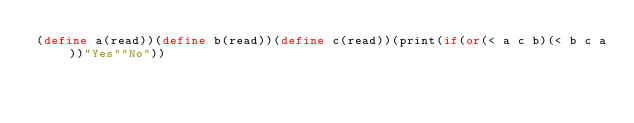Convert code to text. <code><loc_0><loc_0><loc_500><loc_500><_Scheme_>(define a(read))(define b(read))(define c(read))(print(if(or(< a c b)(< b c a))"Yes""No"))</code> 